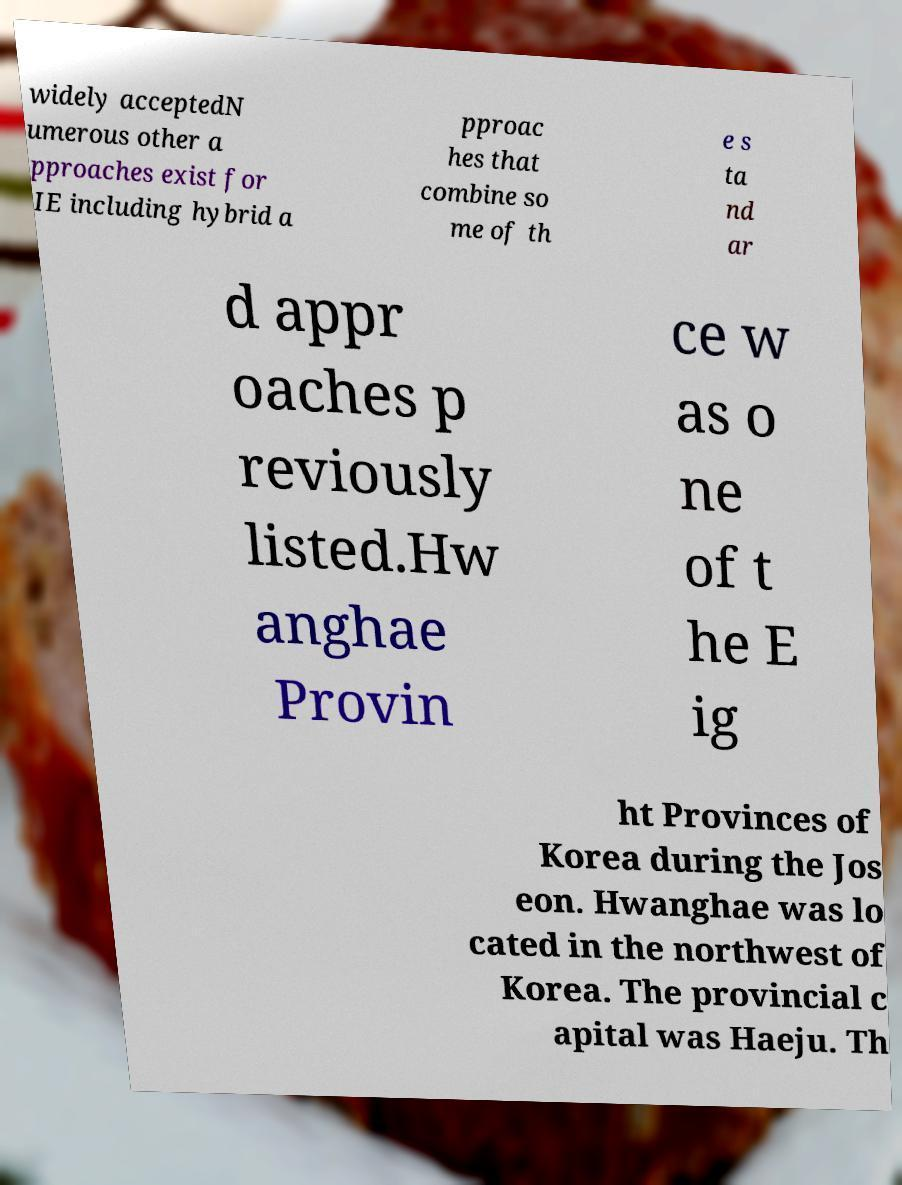What messages or text are displayed in this image? I need them in a readable, typed format. widely acceptedN umerous other a pproaches exist for IE including hybrid a pproac hes that combine so me of th e s ta nd ar d appr oaches p reviously listed.Hw anghae Provin ce w as o ne of t he E ig ht Provinces of Korea during the Jos eon. Hwanghae was lo cated in the northwest of Korea. The provincial c apital was Haeju. Th 